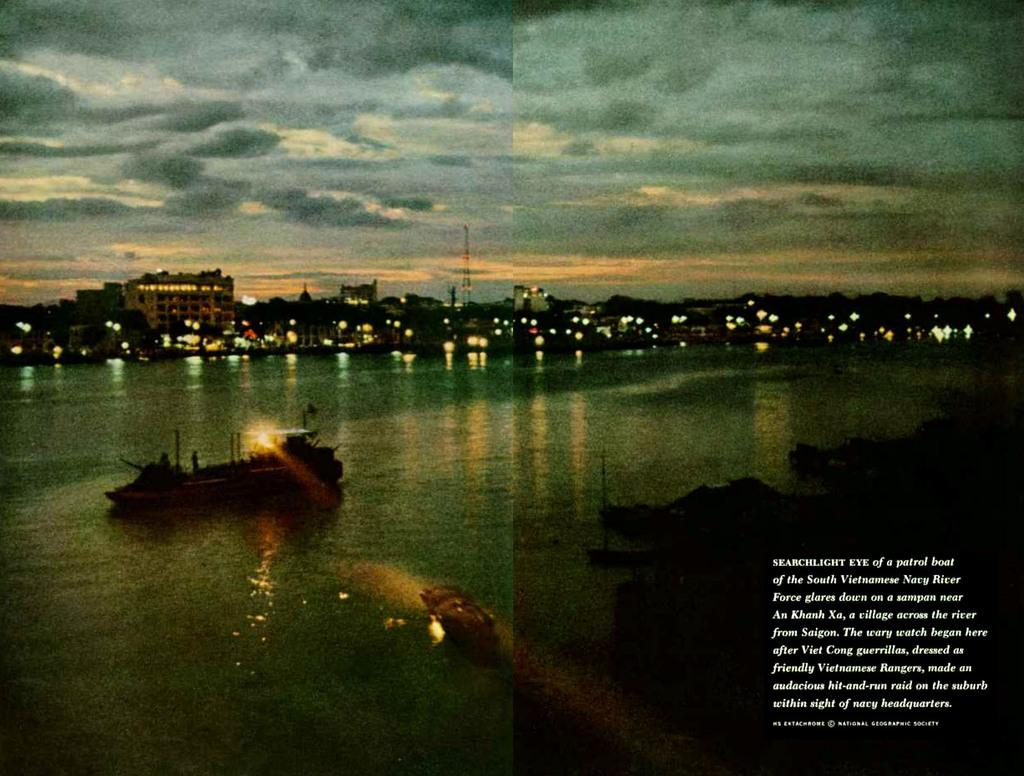What type of picture is the image? The image is an edited picture. What can be seen in the image besides the editing? There are buildings, lights, water, and objects visible in the image. Can you describe the lighting in the image? There are lights visible in the image. What is the condition of the right side of the image? The right side of the image is dark. Is there any text present in the image? Yes, there is text visible on the right side of the image. What type of vegetable is being used as a prop in the image? There is no vegetable present in the image; it features an edited picture with buildings, lights, water, and objects. What is the name of the person who created the image? The name of the person who created the image is not mentioned in the provided facts. 